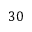<formula> <loc_0><loc_0><loc_500><loc_500>3 0</formula> 